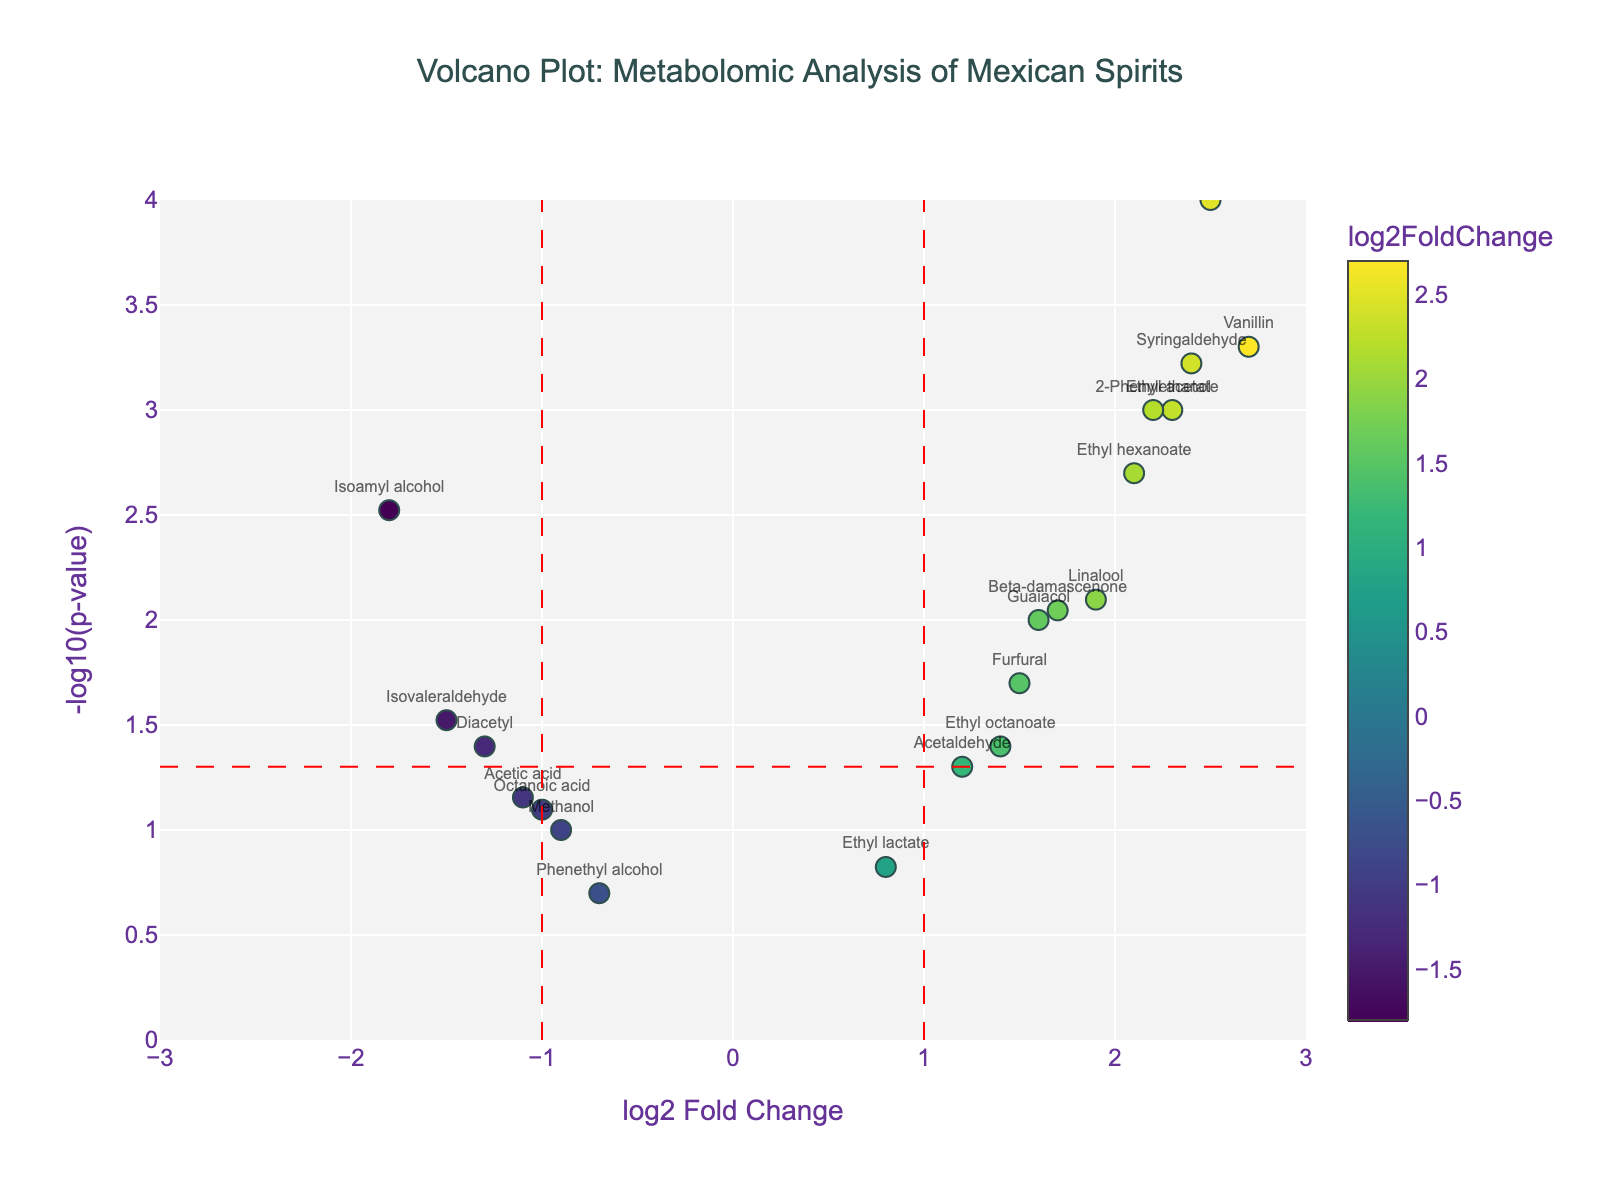Which compound has the highest log2 fold change? Scan the x-axis values to determine which point lies furthest to the right. The compound with the highest log2 fold change is represented by the furthest point on the right.
Answer: Vanillin Which compound has the lowest p-value? Check the y-axis values to find the highest point on the plot. The compound with the lowest p-value will be at the top of the plot due to the -log10 transformation.
Answer: Eugenol How many significant compounds have a log2 fold change greater than 1 and a p-value less than 0.05? Identify data points in the upper right quadrant of the plot, above the horizontal red line (p-value < 0.05) and to the right of the vertical red line at log2 fold change = 1. Count these points.
Answer: 6 Which compound is associated with a negative log2 fold change of less than -1? Find the points located on the left side of the vertical red line at log2 fold change = -1. Only consider points below or equal to this line and identify the compounds.
Answer: Isoamyl alcohol, Diacetyl, Isovaleraldehyde What is the log2 fold change for Furfural? Locate the data point labeled "Furfural" on the plot and read its x-axis value (log2 fold change).
Answer: 1.5 Which compound shows a log2 fold change close to zero but is not significant (p-value > 0.05)? Look for data points near the x-axis value of zero and check their position relative to the horizontal red line at -log10(p-value) = -log10(0.05). Any point close to zero and below this line qualifies.
Answer: Phenethyl alcohol, Methanol, Acetic acid, Ethyl lactate, Octanoic acid What is the p-value range for the significant compounds with a positive log2 fold change? Identify significant points on the right of the plot (log2 fold change > 1) and determine their y-axis values to get the range of their p-values.
Answer: Between 0.0001 and 0.04 Compare the log2 fold change values of Ethyl acetate and Isoamyl alcohol. Which one shows a higher fold change? Identify the positions of Ethyl acetate and Isoamyl alcohol on the x-axis and compare their log2 fold change values. The compound further to the right has the higher value.
Answer: Ethyl acetate 